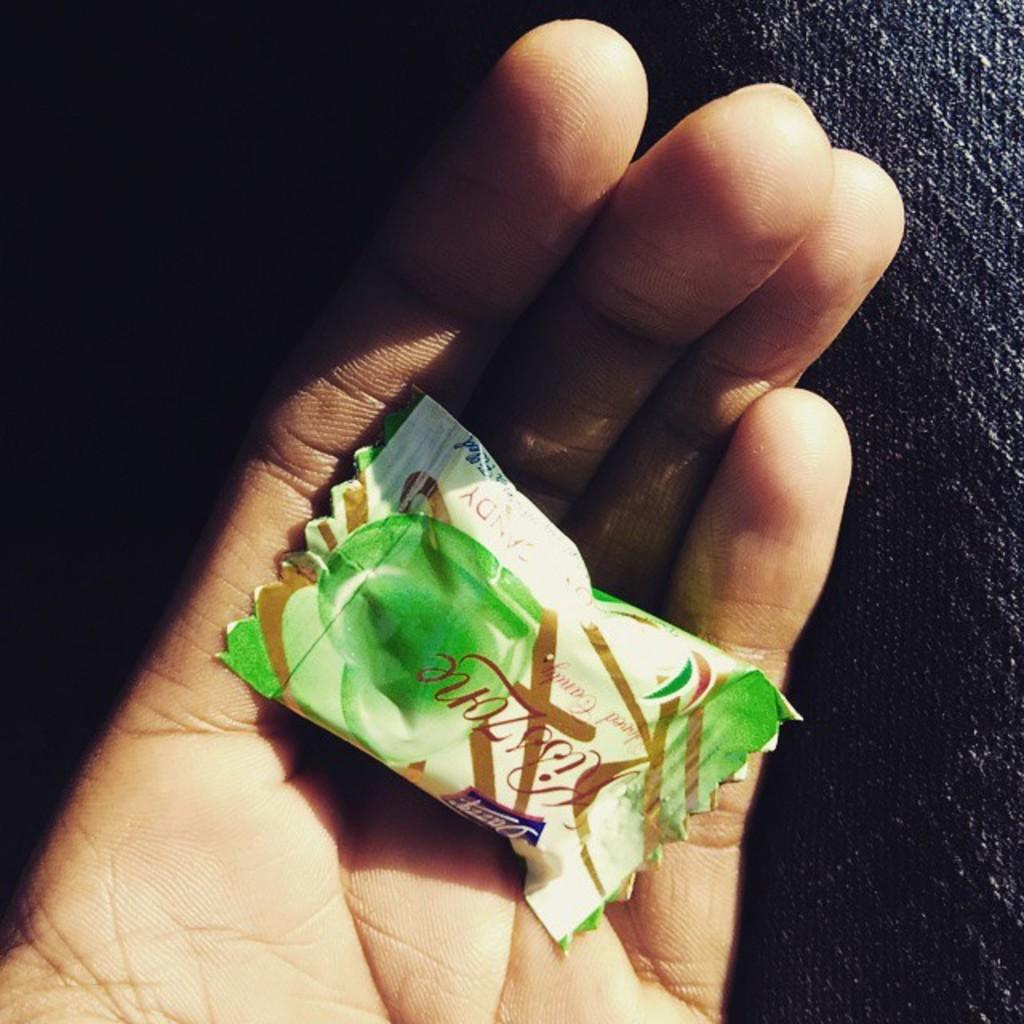What is being held in the hand in the image? There is a chocolate in the hand in the image. Can you describe the setting of the image? The image shows a hand holding a chocolate, and there appears to be a cloth on the right side of the image. What news is being reported in the image? There is no news being reported in the image; it only shows a hand holding a chocolate and a cloth on the right side. 